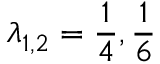Convert formula to latex. <formula><loc_0><loc_0><loc_500><loc_500>\lambda _ { 1 , 2 } = \frac { 1 } { 4 } , \frac { 1 } { 6 }</formula> 